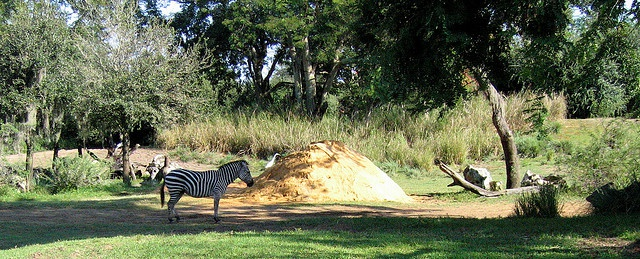Describe the objects in this image and their specific colors. I can see a zebra in darkgreen, black, gray, and darkgray tones in this image. 